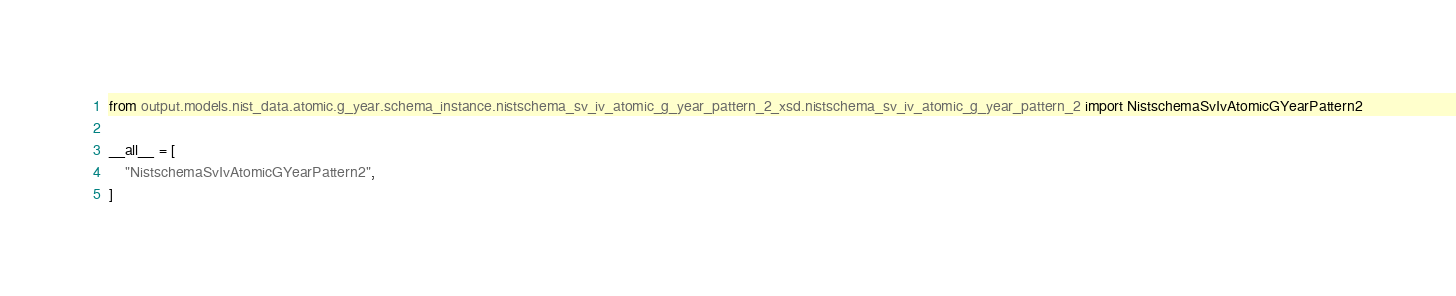<code> <loc_0><loc_0><loc_500><loc_500><_Python_>from output.models.nist_data.atomic.g_year.schema_instance.nistschema_sv_iv_atomic_g_year_pattern_2_xsd.nistschema_sv_iv_atomic_g_year_pattern_2 import NistschemaSvIvAtomicGYearPattern2

__all__ = [
    "NistschemaSvIvAtomicGYearPattern2",
]
</code> 